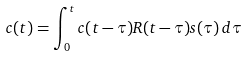Convert formula to latex. <formula><loc_0><loc_0><loc_500><loc_500>c ( t ) = \int _ { 0 } ^ { t } c ( t - \tau ) R ( t - \tau ) s ( \tau ) \, d \tau</formula> 